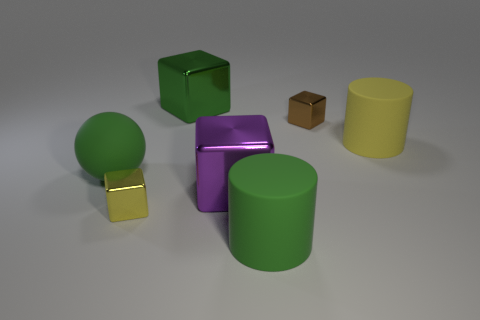What number of large purple things have the same material as the yellow cylinder?
Your answer should be compact. 0. There is a rubber thing that is both right of the large green shiny thing and on the left side of the small brown metallic object; what shape is it?
Offer a terse response. Cylinder. How many things are tiny brown metallic cubes in front of the green metallic thing or small metal objects on the right side of the tiny yellow object?
Provide a short and direct response. 1. Are there the same number of cubes that are behind the big purple metal block and large blocks that are in front of the small brown object?
Offer a terse response. No. What is the shape of the object to the right of the metal block that is to the right of the large purple block?
Ensure brevity in your answer.  Cylinder. Are there any other things of the same shape as the large yellow object?
Offer a terse response. Yes. How many brown spheres are there?
Offer a very short reply. 0. Are the small object that is on the left side of the small brown metal object and the tiny brown object made of the same material?
Your answer should be compact. Yes. Is there a blue rubber cube that has the same size as the ball?
Keep it short and to the point. No. Does the tiny brown metal object have the same shape as the big matte thing in front of the big green sphere?
Provide a succinct answer. No. 